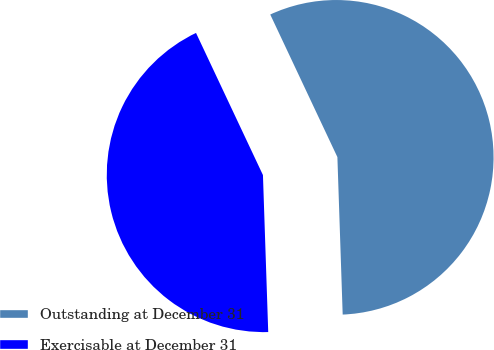<chart> <loc_0><loc_0><loc_500><loc_500><pie_chart><fcel>Outstanding at December 31<fcel>Exercisable at December 31<nl><fcel>56.47%<fcel>43.53%<nl></chart> 